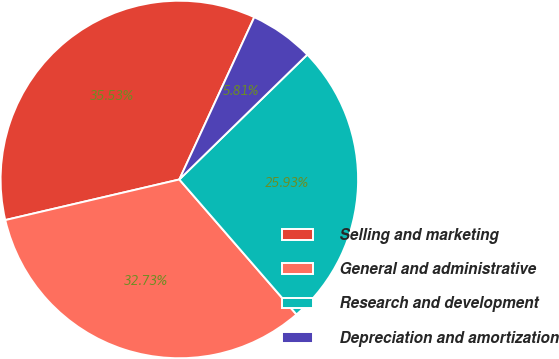<chart> <loc_0><loc_0><loc_500><loc_500><pie_chart><fcel>Selling and marketing<fcel>General and administrative<fcel>Research and development<fcel>Depreciation and amortization<nl><fcel>35.53%<fcel>32.73%<fcel>25.93%<fcel>5.81%<nl></chart> 